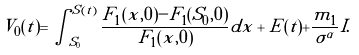<formula> <loc_0><loc_0><loc_500><loc_500>V _ { 0 } ( t ) = \int ^ { S ( t ) } _ { S _ { 0 } } \frac { F _ { 1 } ( x , 0 ) - F _ { 1 } ( S _ { 0 } , 0 ) } { F _ { 1 } ( x , 0 ) } d x + E ( t ) + \frac { m _ { 1 } } { \sigma ^ { \alpha } } I .</formula> 